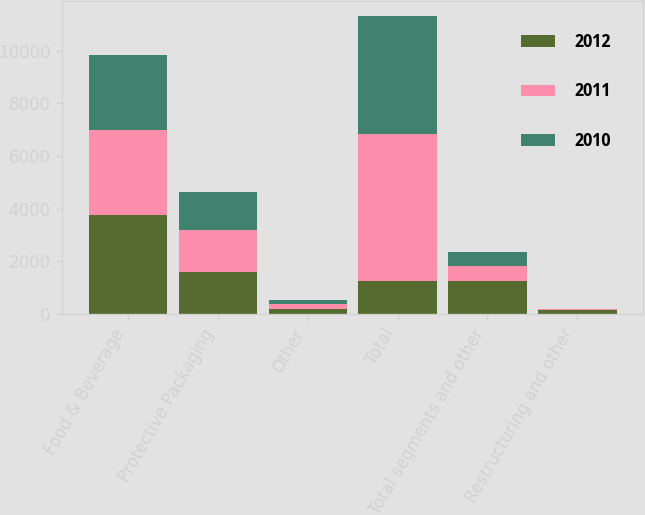Convert chart to OTSL. <chart><loc_0><loc_0><loc_500><loc_500><stacked_bar_chart><ecel><fcel>Food & Beverage<fcel>Protective Packaging<fcel>Other<fcel>Total<fcel>Total segments and other<fcel>Restructuring and other<nl><fcel>2012<fcel>3739.6<fcel>1578.4<fcel>198.6<fcel>1267.2<fcel>1267.2<fcel>142.5<nl><fcel>2011<fcel>3240.6<fcel>1594.4<fcel>181.9<fcel>5550.9<fcel>546.4<fcel>52.2<nl><fcel>2010<fcel>2858.5<fcel>1469.9<fcel>161.7<fcel>4490.1<fcel>542.6<fcel>7.6<nl></chart> 